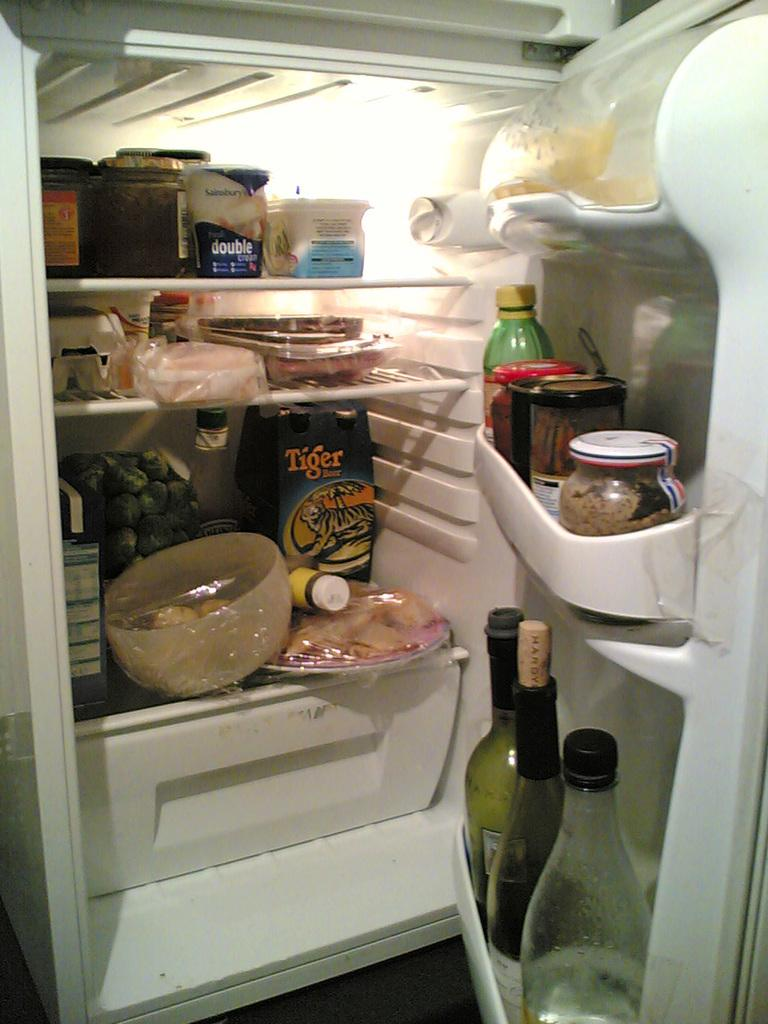<image>
Present a compact description of the photo's key features. An opened full fridge with a box of Tiger beer in it as well 